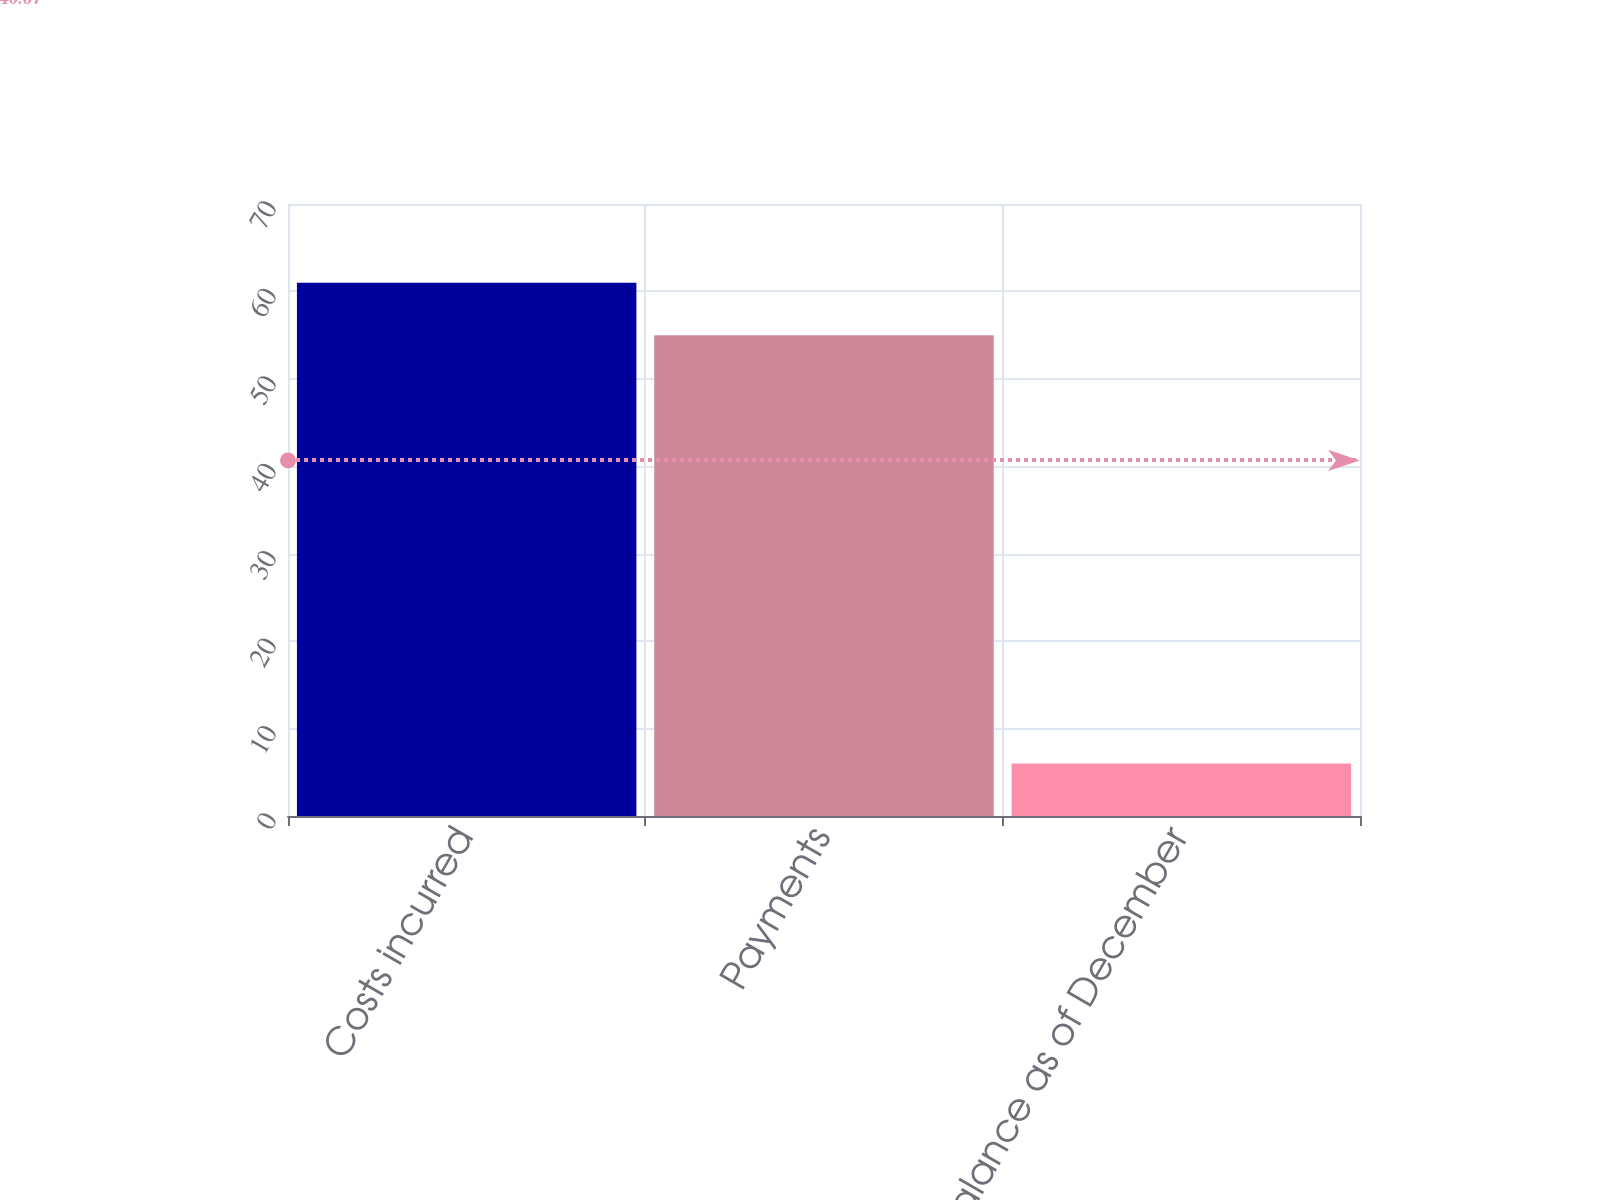<chart> <loc_0><loc_0><loc_500><loc_500><bar_chart><fcel>Costs incurred<fcel>Payments<fcel>Accrued balance as of December<nl><fcel>61<fcel>55<fcel>6<nl></chart> 